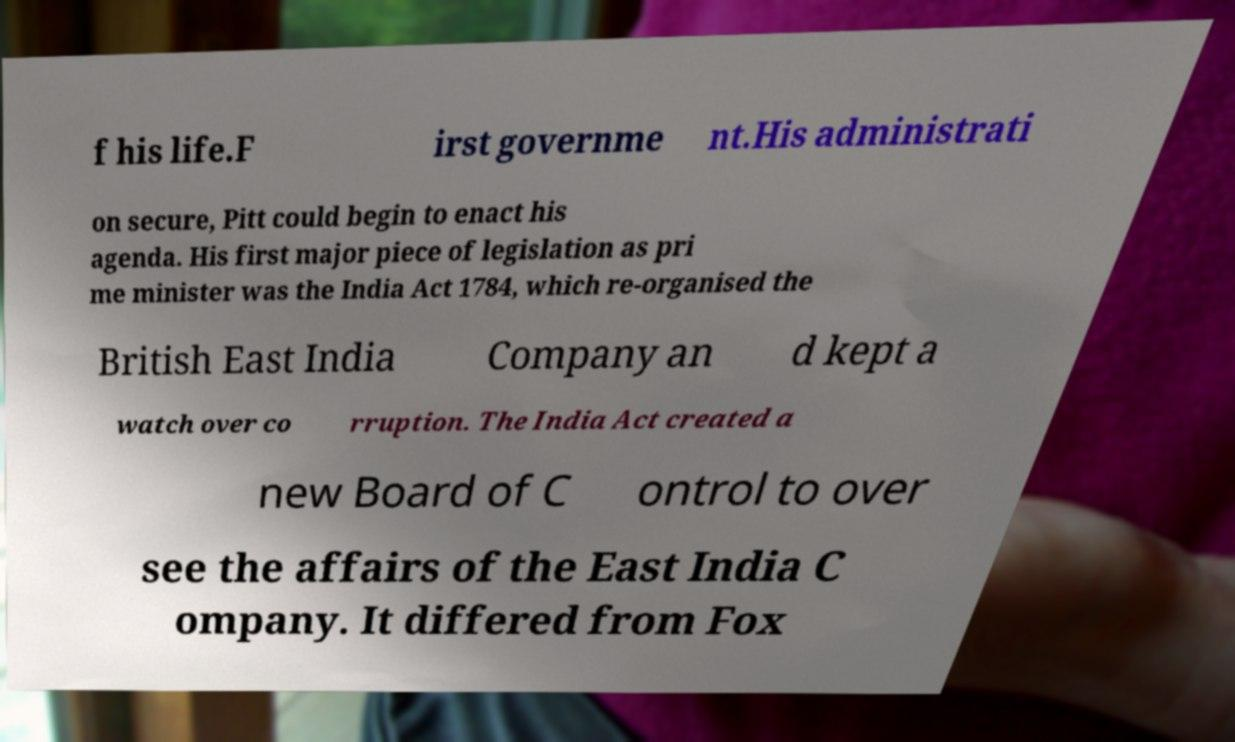For documentation purposes, I need the text within this image transcribed. Could you provide that? f his life.F irst governme nt.His administrati on secure, Pitt could begin to enact his agenda. His first major piece of legislation as pri me minister was the India Act 1784, which re-organised the British East India Company an d kept a watch over co rruption. The India Act created a new Board of C ontrol to over see the affairs of the East India C ompany. It differed from Fox 